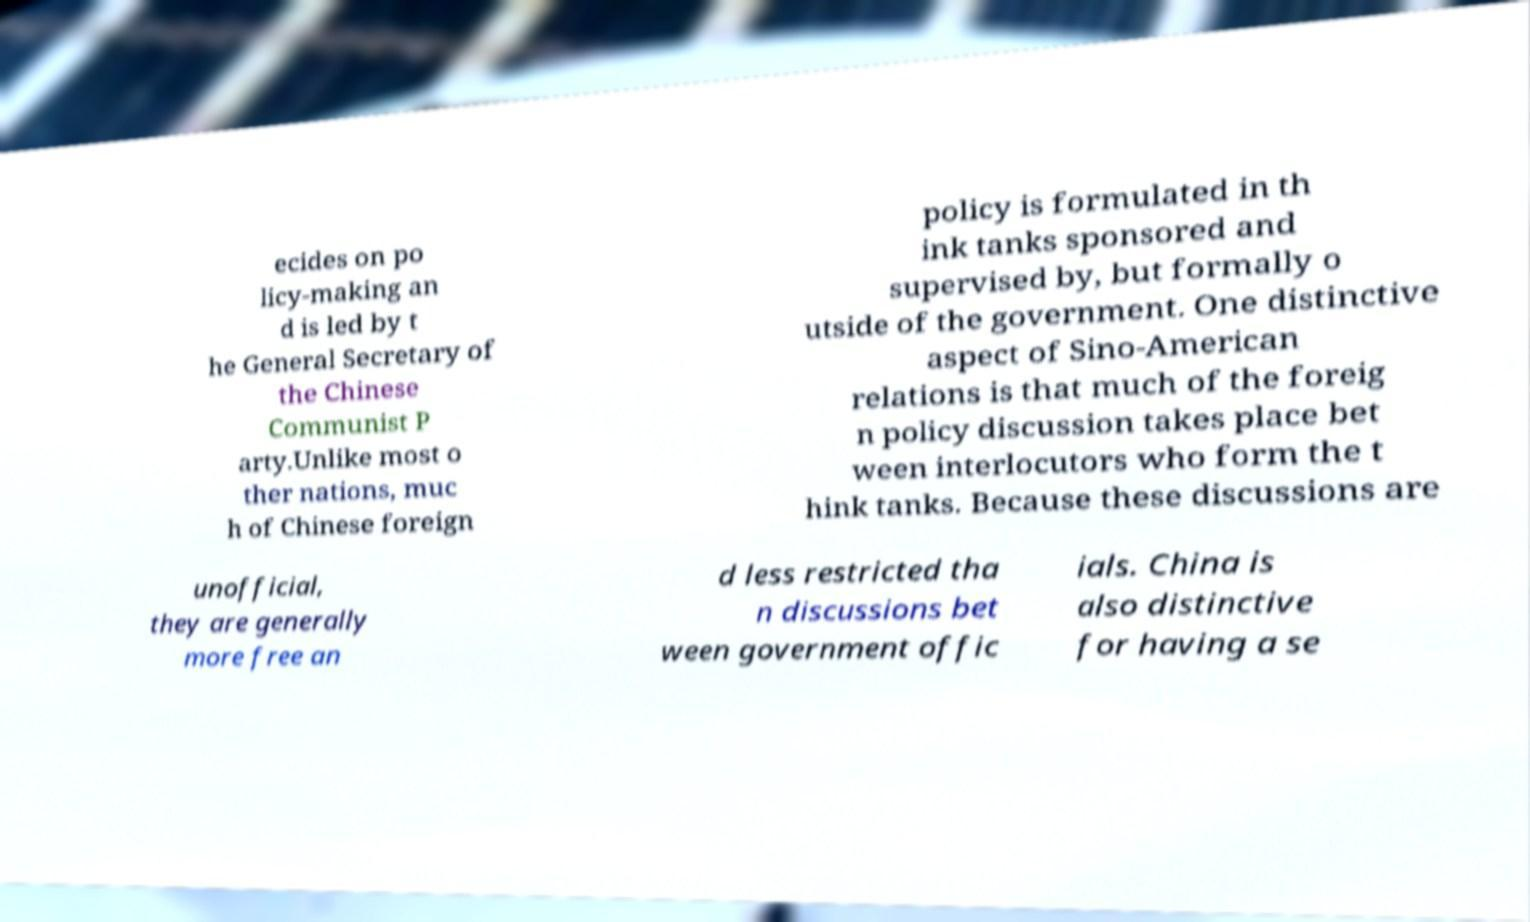There's text embedded in this image that I need extracted. Can you transcribe it verbatim? ecides on po licy-making an d is led by t he General Secretary of the Chinese Communist P arty.Unlike most o ther nations, muc h of Chinese foreign policy is formulated in th ink tanks sponsored and supervised by, but formally o utside of the government. One distinctive aspect of Sino-American relations is that much of the foreig n policy discussion takes place bet ween interlocutors who form the t hink tanks. Because these discussions are unofficial, they are generally more free an d less restricted tha n discussions bet ween government offic ials. China is also distinctive for having a se 